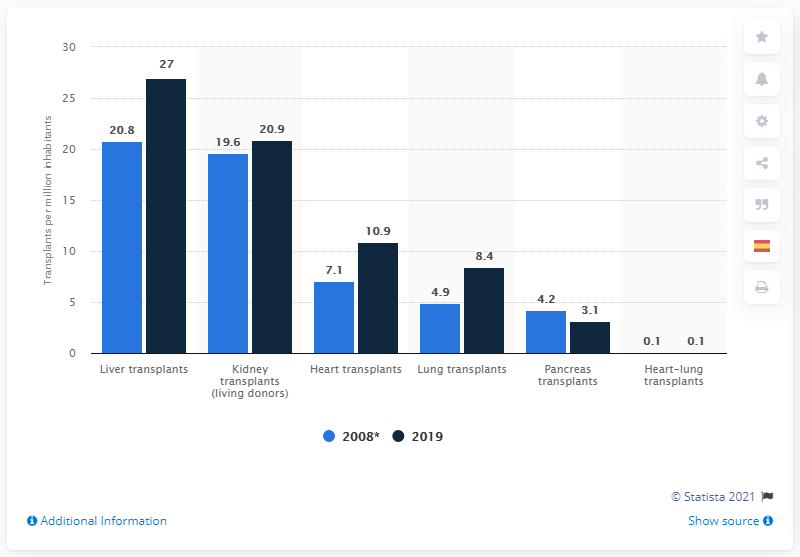List a handful of essential elements in this visual. In 2019, the highest number of liver transplants was performed. In 2008, the number of lung transplants performed per million inhabitants in the United States was 4.9. In 2019, the highest rates of transplants were conducted. 